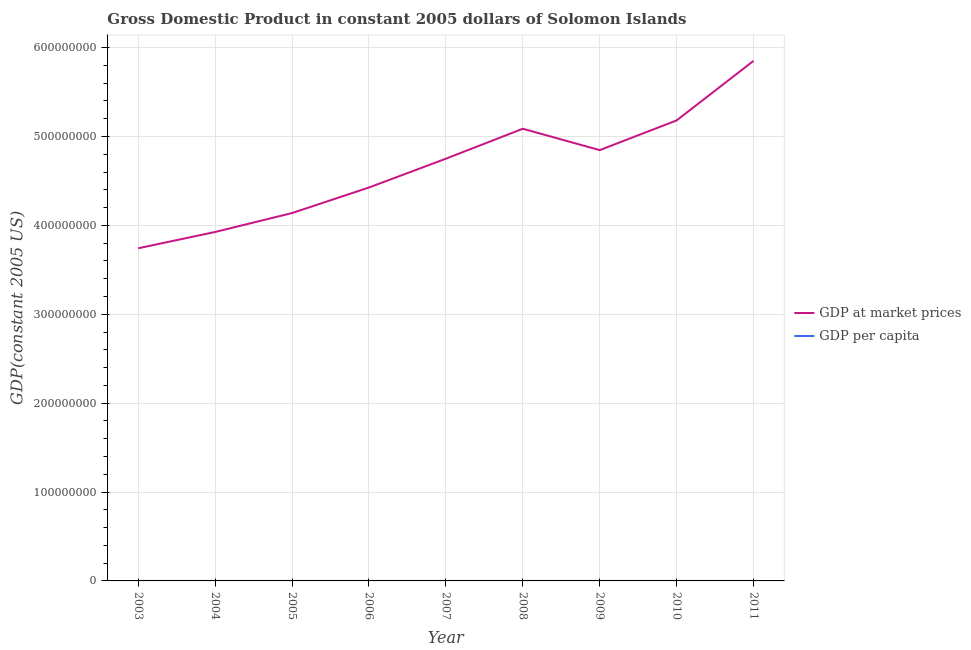How many different coloured lines are there?
Give a very brief answer. 2. Is the number of lines equal to the number of legend labels?
Your answer should be compact. Yes. What is the gdp per capita in 2009?
Ensure brevity in your answer.  941.62. Across all years, what is the maximum gdp per capita?
Provide a short and direct response. 1088.31. Across all years, what is the minimum gdp per capita?
Provide a succinct answer. 838.56. In which year was the gdp at market prices minimum?
Keep it short and to the point. 2003. What is the total gdp at market prices in the graph?
Offer a very short reply. 4.20e+09. What is the difference between the gdp at market prices in 2005 and that in 2011?
Ensure brevity in your answer.  -1.71e+08. What is the difference between the gdp per capita in 2004 and the gdp at market prices in 2007?
Your answer should be very brief. -4.75e+08. What is the average gdp per capita per year?
Provide a short and direct response. 943.3. In the year 2011, what is the difference between the gdp per capita and gdp at market prices?
Your answer should be very brief. -5.85e+08. In how many years, is the gdp at market prices greater than 220000000 US$?
Keep it short and to the point. 9. What is the ratio of the gdp at market prices in 2004 to that in 2006?
Your answer should be compact. 0.89. Is the gdp at market prices in 2006 less than that in 2008?
Provide a succinct answer. Yes. Is the difference between the gdp at market prices in 2004 and 2007 greater than the difference between the gdp per capita in 2004 and 2007?
Your answer should be very brief. No. What is the difference between the highest and the second highest gdp at market prices?
Your response must be concise. 6.70e+07. What is the difference between the highest and the lowest gdp per capita?
Your answer should be very brief. 249.75. Is the sum of the gdp per capita in 2004 and 2009 greater than the maximum gdp at market prices across all years?
Provide a succinct answer. No. Is the gdp per capita strictly less than the gdp at market prices over the years?
Your answer should be compact. Yes. How many lines are there?
Your answer should be compact. 2. How many years are there in the graph?
Offer a terse response. 9. Does the graph contain grids?
Your answer should be very brief. Yes. What is the title of the graph?
Make the answer very short. Gross Domestic Product in constant 2005 dollars of Solomon Islands. What is the label or title of the X-axis?
Provide a succinct answer. Year. What is the label or title of the Y-axis?
Give a very brief answer. GDP(constant 2005 US). What is the GDP(constant 2005 US) of GDP at market prices in 2003?
Your answer should be very brief. 3.74e+08. What is the GDP(constant 2005 US) of GDP per capita in 2003?
Your response must be concise. 838.56. What is the GDP(constant 2005 US) in GDP at market prices in 2004?
Provide a succinct answer. 3.93e+08. What is the GDP(constant 2005 US) in GDP per capita in 2004?
Your response must be concise. 857.56. What is the GDP(constant 2005 US) of GDP at market prices in 2005?
Offer a terse response. 4.14e+08. What is the GDP(constant 2005 US) in GDP per capita in 2005?
Offer a very short reply. 881.96. What is the GDP(constant 2005 US) in GDP at market prices in 2006?
Make the answer very short. 4.43e+08. What is the GDP(constant 2005 US) in GDP per capita in 2006?
Offer a terse response. 920.84. What is the GDP(constant 2005 US) of GDP at market prices in 2007?
Offer a very short reply. 4.75e+08. What is the GDP(constant 2005 US) in GDP per capita in 2007?
Provide a short and direct response. 965.44. What is the GDP(constant 2005 US) in GDP at market prices in 2008?
Offer a terse response. 5.09e+08. What is the GDP(constant 2005 US) in GDP per capita in 2008?
Make the answer very short. 1010.65. What is the GDP(constant 2005 US) of GDP at market prices in 2009?
Give a very brief answer. 4.85e+08. What is the GDP(constant 2005 US) of GDP per capita in 2009?
Ensure brevity in your answer.  941.62. What is the GDP(constant 2005 US) of GDP at market prices in 2010?
Offer a very short reply. 5.18e+08. What is the GDP(constant 2005 US) of GDP per capita in 2010?
Your response must be concise. 984.73. What is the GDP(constant 2005 US) of GDP at market prices in 2011?
Provide a short and direct response. 5.85e+08. What is the GDP(constant 2005 US) of GDP per capita in 2011?
Give a very brief answer. 1088.31. Across all years, what is the maximum GDP(constant 2005 US) in GDP at market prices?
Your answer should be very brief. 5.85e+08. Across all years, what is the maximum GDP(constant 2005 US) of GDP per capita?
Your answer should be very brief. 1088.31. Across all years, what is the minimum GDP(constant 2005 US) of GDP at market prices?
Make the answer very short. 3.74e+08. Across all years, what is the minimum GDP(constant 2005 US) in GDP per capita?
Your answer should be very brief. 838.56. What is the total GDP(constant 2005 US) of GDP at market prices in the graph?
Offer a very short reply. 4.20e+09. What is the total GDP(constant 2005 US) in GDP per capita in the graph?
Your response must be concise. 8489.68. What is the difference between the GDP(constant 2005 US) of GDP at market prices in 2003 and that in 2004?
Your answer should be compact. -1.83e+07. What is the difference between the GDP(constant 2005 US) in GDP per capita in 2003 and that in 2004?
Give a very brief answer. -19. What is the difference between the GDP(constant 2005 US) in GDP at market prices in 2003 and that in 2005?
Make the answer very short. -3.96e+07. What is the difference between the GDP(constant 2005 US) of GDP per capita in 2003 and that in 2005?
Offer a very short reply. -43.41. What is the difference between the GDP(constant 2005 US) of GDP at market prices in 2003 and that in 2006?
Make the answer very short. -6.84e+07. What is the difference between the GDP(constant 2005 US) in GDP per capita in 2003 and that in 2006?
Provide a succinct answer. -82.29. What is the difference between the GDP(constant 2005 US) in GDP at market prices in 2003 and that in 2007?
Your answer should be very brief. -1.01e+08. What is the difference between the GDP(constant 2005 US) of GDP per capita in 2003 and that in 2007?
Offer a very short reply. -126.88. What is the difference between the GDP(constant 2005 US) in GDP at market prices in 2003 and that in 2008?
Your answer should be very brief. -1.34e+08. What is the difference between the GDP(constant 2005 US) of GDP per capita in 2003 and that in 2008?
Your answer should be compact. -172.09. What is the difference between the GDP(constant 2005 US) in GDP at market prices in 2003 and that in 2009?
Your response must be concise. -1.10e+08. What is the difference between the GDP(constant 2005 US) of GDP per capita in 2003 and that in 2009?
Keep it short and to the point. -103.07. What is the difference between the GDP(constant 2005 US) in GDP at market prices in 2003 and that in 2010?
Keep it short and to the point. -1.44e+08. What is the difference between the GDP(constant 2005 US) of GDP per capita in 2003 and that in 2010?
Your response must be concise. -146.17. What is the difference between the GDP(constant 2005 US) in GDP at market prices in 2003 and that in 2011?
Ensure brevity in your answer.  -2.11e+08. What is the difference between the GDP(constant 2005 US) in GDP per capita in 2003 and that in 2011?
Keep it short and to the point. -249.75. What is the difference between the GDP(constant 2005 US) in GDP at market prices in 2004 and that in 2005?
Make the answer very short. -2.13e+07. What is the difference between the GDP(constant 2005 US) of GDP per capita in 2004 and that in 2005?
Ensure brevity in your answer.  -24.4. What is the difference between the GDP(constant 2005 US) of GDP at market prices in 2004 and that in 2006?
Ensure brevity in your answer.  -5.00e+07. What is the difference between the GDP(constant 2005 US) in GDP per capita in 2004 and that in 2006?
Ensure brevity in your answer.  -63.28. What is the difference between the GDP(constant 2005 US) of GDP at market prices in 2004 and that in 2007?
Ensure brevity in your answer.  -8.24e+07. What is the difference between the GDP(constant 2005 US) in GDP per capita in 2004 and that in 2007?
Give a very brief answer. -107.88. What is the difference between the GDP(constant 2005 US) in GDP at market prices in 2004 and that in 2008?
Give a very brief answer. -1.16e+08. What is the difference between the GDP(constant 2005 US) in GDP per capita in 2004 and that in 2008?
Offer a terse response. -153.09. What is the difference between the GDP(constant 2005 US) of GDP at market prices in 2004 and that in 2009?
Offer a very short reply. -9.21e+07. What is the difference between the GDP(constant 2005 US) in GDP per capita in 2004 and that in 2009?
Keep it short and to the point. -84.06. What is the difference between the GDP(constant 2005 US) of GDP at market prices in 2004 and that in 2010?
Provide a succinct answer. -1.26e+08. What is the difference between the GDP(constant 2005 US) in GDP per capita in 2004 and that in 2010?
Make the answer very short. -127.17. What is the difference between the GDP(constant 2005 US) of GDP at market prices in 2004 and that in 2011?
Your response must be concise. -1.93e+08. What is the difference between the GDP(constant 2005 US) in GDP per capita in 2004 and that in 2011?
Your answer should be very brief. -230.75. What is the difference between the GDP(constant 2005 US) of GDP at market prices in 2005 and that in 2006?
Keep it short and to the point. -2.88e+07. What is the difference between the GDP(constant 2005 US) of GDP per capita in 2005 and that in 2006?
Your answer should be very brief. -38.88. What is the difference between the GDP(constant 2005 US) in GDP at market prices in 2005 and that in 2007?
Provide a succinct answer. -6.12e+07. What is the difference between the GDP(constant 2005 US) in GDP per capita in 2005 and that in 2007?
Your answer should be very brief. -83.47. What is the difference between the GDP(constant 2005 US) of GDP at market prices in 2005 and that in 2008?
Offer a very short reply. -9.49e+07. What is the difference between the GDP(constant 2005 US) in GDP per capita in 2005 and that in 2008?
Offer a very short reply. -128.68. What is the difference between the GDP(constant 2005 US) in GDP at market prices in 2005 and that in 2009?
Provide a short and direct response. -7.08e+07. What is the difference between the GDP(constant 2005 US) of GDP per capita in 2005 and that in 2009?
Your response must be concise. -59.66. What is the difference between the GDP(constant 2005 US) in GDP at market prices in 2005 and that in 2010?
Make the answer very short. -1.04e+08. What is the difference between the GDP(constant 2005 US) of GDP per capita in 2005 and that in 2010?
Your answer should be very brief. -102.76. What is the difference between the GDP(constant 2005 US) of GDP at market prices in 2005 and that in 2011?
Provide a succinct answer. -1.71e+08. What is the difference between the GDP(constant 2005 US) of GDP per capita in 2005 and that in 2011?
Offer a very short reply. -206.35. What is the difference between the GDP(constant 2005 US) of GDP at market prices in 2006 and that in 2007?
Make the answer very short. -3.24e+07. What is the difference between the GDP(constant 2005 US) of GDP per capita in 2006 and that in 2007?
Ensure brevity in your answer.  -44.59. What is the difference between the GDP(constant 2005 US) of GDP at market prices in 2006 and that in 2008?
Your response must be concise. -6.61e+07. What is the difference between the GDP(constant 2005 US) in GDP per capita in 2006 and that in 2008?
Your answer should be very brief. -89.81. What is the difference between the GDP(constant 2005 US) of GDP at market prices in 2006 and that in 2009?
Offer a terse response. -4.21e+07. What is the difference between the GDP(constant 2005 US) in GDP per capita in 2006 and that in 2009?
Your answer should be compact. -20.78. What is the difference between the GDP(constant 2005 US) in GDP at market prices in 2006 and that in 2010?
Offer a very short reply. -7.55e+07. What is the difference between the GDP(constant 2005 US) of GDP per capita in 2006 and that in 2010?
Your response must be concise. -63.88. What is the difference between the GDP(constant 2005 US) in GDP at market prices in 2006 and that in 2011?
Your answer should be compact. -1.42e+08. What is the difference between the GDP(constant 2005 US) in GDP per capita in 2006 and that in 2011?
Your answer should be very brief. -167.47. What is the difference between the GDP(constant 2005 US) of GDP at market prices in 2007 and that in 2008?
Give a very brief answer. -3.37e+07. What is the difference between the GDP(constant 2005 US) in GDP per capita in 2007 and that in 2008?
Offer a terse response. -45.21. What is the difference between the GDP(constant 2005 US) in GDP at market prices in 2007 and that in 2009?
Provide a succinct answer. -9.65e+06. What is the difference between the GDP(constant 2005 US) of GDP per capita in 2007 and that in 2009?
Offer a very short reply. 23.81. What is the difference between the GDP(constant 2005 US) of GDP at market prices in 2007 and that in 2010?
Ensure brevity in your answer.  -4.31e+07. What is the difference between the GDP(constant 2005 US) in GDP per capita in 2007 and that in 2010?
Offer a very short reply. -19.29. What is the difference between the GDP(constant 2005 US) in GDP at market prices in 2007 and that in 2011?
Make the answer very short. -1.10e+08. What is the difference between the GDP(constant 2005 US) of GDP per capita in 2007 and that in 2011?
Provide a succinct answer. -122.87. What is the difference between the GDP(constant 2005 US) of GDP at market prices in 2008 and that in 2009?
Offer a terse response. 2.41e+07. What is the difference between the GDP(constant 2005 US) in GDP per capita in 2008 and that in 2009?
Provide a succinct answer. 69.03. What is the difference between the GDP(constant 2005 US) of GDP at market prices in 2008 and that in 2010?
Keep it short and to the point. -9.37e+06. What is the difference between the GDP(constant 2005 US) in GDP per capita in 2008 and that in 2010?
Your answer should be compact. 25.92. What is the difference between the GDP(constant 2005 US) of GDP at market prices in 2008 and that in 2011?
Your answer should be very brief. -7.64e+07. What is the difference between the GDP(constant 2005 US) in GDP per capita in 2008 and that in 2011?
Provide a short and direct response. -77.66. What is the difference between the GDP(constant 2005 US) in GDP at market prices in 2009 and that in 2010?
Ensure brevity in your answer.  -3.34e+07. What is the difference between the GDP(constant 2005 US) in GDP per capita in 2009 and that in 2010?
Your answer should be very brief. -43.1. What is the difference between the GDP(constant 2005 US) in GDP at market prices in 2009 and that in 2011?
Your answer should be compact. -1.00e+08. What is the difference between the GDP(constant 2005 US) of GDP per capita in 2009 and that in 2011?
Keep it short and to the point. -146.69. What is the difference between the GDP(constant 2005 US) of GDP at market prices in 2010 and that in 2011?
Ensure brevity in your answer.  -6.70e+07. What is the difference between the GDP(constant 2005 US) of GDP per capita in 2010 and that in 2011?
Make the answer very short. -103.58. What is the difference between the GDP(constant 2005 US) in GDP at market prices in 2003 and the GDP(constant 2005 US) in GDP per capita in 2004?
Your answer should be compact. 3.74e+08. What is the difference between the GDP(constant 2005 US) in GDP at market prices in 2003 and the GDP(constant 2005 US) in GDP per capita in 2005?
Your response must be concise. 3.74e+08. What is the difference between the GDP(constant 2005 US) in GDP at market prices in 2003 and the GDP(constant 2005 US) in GDP per capita in 2006?
Provide a short and direct response. 3.74e+08. What is the difference between the GDP(constant 2005 US) of GDP at market prices in 2003 and the GDP(constant 2005 US) of GDP per capita in 2007?
Your response must be concise. 3.74e+08. What is the difference between the GDP(constant 2005 US) of GDP at market prices in 2003 and the GDP(constant 2005 US) of GDP per capita in 2008?
Your answer should be compact. 3.74e+08. What is the difference between the GDP(constant 2005 US) of GDP at market prices in 2003 and the GDP(constant 2005 US) of GDP per capita in 2009?
Ensure brevity in your answer.  3.74e+08. What is the difference between the GDP(constant 2005 US) in GDP at market prices in 2003 and the GDP(constant 2005 US) in GDP per capita in 2010?
Offer a terse response. 3.74e+08. What is the difference between the GDP(constant 2005 US) of GDP at market prices in 2003 and the GDP(constant 2005 US) of GDP per capita in 2011?
Your answer should be very brief. 3.74e+08. What is the difference between the GDP(constant 2005 US) in GDP at market prices in 2004 and the GDP(constant 2005 US) in GDP per capita in 2005?
Provide a short and direct response. 3.93e+08. What is the difference between the GDP(constant 2005 US) in GDP at market prices in 2004 and the GDP(constant 2005 US) in GDP per capita in 2006?
Your response must be concise. 3.93e+08. What is the difference between the GDP(constant 2005 US) in GDP at market prices in 2004 and the GDP(constant 2005 US) in GDP per capita in 2007?
Ensure brevity in your answer.  3.93e+08. What is the difference between the GDP(constant 2005 US) of GDP at market prices in 2004 and the GDP(constant 2005 US) of GDP per capita in 2008?
Your answer should be compact. 3.93e+08. What is the difference between the GDP(constant 2005 US) of GDP at market prices in 2004 and the GDP(constant 2005 US) of GDP per capita in 2009?
Offer a terse response. 3.93e+08. What is the difference between the GDP(constant 2005 US) in GDP at market prices in 2004 and the GDP(constant 2005 US) in GDP per capita in 2010?
Your response must be concise. 3.93e+08. What is the difference between the GDP(constant 2005 US) in GDP at market prices in 2004 and the GDP(constant 2005 US) in GDP per capita in 2011?
Provide a succinct answer. 3.93e+08. What is the difference between the GDP(constant 2005 US) of GDP at market prices in 2005 and the GDP(constant 2005 US) of GDP per capita in 2006?
Your response must be concise. 4.14e+08. What is the difference between the GDP(constant 2005 US) of GDP at market prices in 2005 and the GDP(constant 2005 US) of GDP per capita in 2007?
Offer a terse response. 4.14e+08. What is the difference between the GDP(constant 2005 US) in GDP at market prices in 2005 and the GDP(constant 2005 US) in GDP per capita in 2008?
Offer a terse response. 4.14e+08. What is the difference between the GDP(constant 2005 US) of GDP at market prices in 2005 and the GDP(constant 2005 US) of GDP per capita in 2009?
Give a very brief answer. 4.14e+08. What is the difference between the GDP(constant 2005 US) of GDP at market prices in 2005 and the GDP(constant 2005 US) of GDP per capita in 2010?
Offer a terse response. 4.14e+08. What is the difference between the GDP(constant 2005 US) of GDP at market prices in 2005 and the GDP(constant 2005 US) of GDP per capita in 2011?
Your response must be concise. 4.14e+08. What is the difference between the GDP(constant 2005 US) in GDP at market prices in 2006 and the GDP(constant 2005 US) in GDP per capita in 2007?
Ensure brevity in your answer.  4.43e+08. What is the difference between the GDP(constant 2005 US) of GDP at market prices in 2006 and the GDP(constant 2005 US) of GDP per capita in 2008?
Provide a short and direct response. 4.43e+08. What is the difference between the GDP(constant 2005 US) of GDP at market prices in 2006 and the GDP(constant 2005 US) of GDP per capita in 2009?
Provide a short and direct response. 4.43e+08. What is the difference between the GDP(constant 2005 US) of GDP at market prices in 2006 and the GDP(constant 2005 US) of GDP per capita in 2010?
Offer a terse response. 4.43e+08. What is the difference between the GDP(constant 2005 US) in GDP at market prices in 2006 and the GDP(constant 2005 US) in GDP per capita in 2011?
Offer a very short reply. 4.43e+08. What is the difference between the GDP(constant 2005 US) in GDP at market prices in 2007 and the GDP(constant 2005 US) in GDP per capita in 2008?
Ensure brevity in your answer.  4.75e+08. What is the difference between the GDP(constant 2005 US) of GDP at market prices in 2007 and the GDP(constant 2005 US) of GDP per capita in 2009?
Your answer should be compact. 4.75e+08. What is the difference between the GDP(constant 2005 US) of GDP at market prices in 2007 and the GDP(constant 2005 US) of GDP per capita in 2010?
Keep it short and to the point. 4.75e+08. What is the difference between the GDP(constant 2005 US) of GDP at market prices in 2007 and the GDP(constant 2005 US) of GDP per capita in 2011?
Provide a short and direct response. 4.75e+08. What is the difference between the GDP(constant 2005 US) in GDP at market prices in 2008 and the GDP(constant 2005 US) in GDP per capita in 2009?
Provide a succinct answer. 5.09e+08. What is the difference between the GDP(constant 2005 US) of GDP at market prices in 2008 and the GDP(constant 2005 US) of GDP per capita in 2010?
Provide a short and direct response. 5.09e+08. What is the difference between the GDP(constant 2005 US) of GDP at market prices in 2008 and the GDP(constant 2005 US) of GDP per capita in 2011?
Offer a terse response. 5.09e+08. What is the difference between the GDP(constant 2005 US) of GDP at market prices in 2009 and the GDP(constant 2005 US) of GDP per capita in 2010?
Your answer should be very brief. 4.85e+08. What is the difference between the GDP(constant 2005 US) of GDP at market prices in 2009 and the GDP(constant 2005 US) of GDP per capita in 2011?
Give a very brief answer. 4.85e+08. What is the difference between the GDP(constant 2005 US) in GDP at market prices in 2010 and the GDP(constant 2005 US) in GDP per capita in 2011?
Offer a terse response. 5.18e+08. What is the average GDP(constant 2005 US) of GDP at market prices per year?
Ensure brevity in your answer.  4.66e+08. What is the average GDP(constant 2005 US) in GDP per capita per year?
Offer a terse response. 943.3. In the year 2003, what is the difference between the GDP(constant 2005 US) in GDP at market prices and GDP(constant 2005 US) in GDP per capita?
Your answer should be compact. 3.74e+08. In the year 2004, what is the difference between the GDP(constant 2005 US) in GDP at market prices and GDP(constant 2005 US) in GDP per capita?
Provide a succinct answer. 3.93e+08. In the year 2005, what is the difference between the GDP(constant 2005 US) in GDP at market prices and GDP(constant 2005 US) in GDP per capita?
Ensure brevity in your answer.  4.14e+08. In the year 2006, what is the difference between the GDP(constant 2005 US) of GDP at market prices and GDP(constant 2005 US) of GDP per capita?
Keep it short and to the point. 4.43e+08. In the year 2007, what is the difference between the GDP(constant 2005 US) of GDP at market prices and GDP(constant 2005 US) of GDP per capita?
Make the answer very short. 4.75e+08. In the year 2008, what is the difference between the GDP(constant 2005 US) of GDP at market prices and GDP(constant 2005 US) of GDP per capita?
Give a very brief answer. 5.09e+08. In the year 2009, what is the difference between the GDP(constant 2005 US) of GDP at market prices and GDP(constant 2005 US) of GDP per capita?
Keep it short and to the point. 4.85e+08. In the year 2010, what is the difference between the GDP(constant 2005 US) in GDP at market prices and GDP(constant 2005 US) in GDP per capita?
Give a very brief answer. 5.18e+08. In the year 2011, what is the difference between the GDP(constant 2005 US) in GDP at market prices and GDP(constant 2005 US) in GDP per capita?
Your answer should be very brief. 5.85e+08. What is the ratio of the GDP(constant 2005 US) in GDP at market prices in 2003 to that in 2004?
Keep it short and to the point. 0.95. What is the ratio of the GDP(constant 2005 US) of GDP per capita in 2003 to that in 2004?
Give a very brief answer. 0.98. What is the ratio of the GDP(constant 2005 US) of GDP at market prices in 2003 to that in 2005?
Provide a short and direct response. 0.9. What is the ratio of the GDP(constant 2005 US) in GDP per capita in 2003 to that in 2005?
Your answer should be very brief. 0.95. What is the ratio of the GDP(constant 2005 US) of GDP at market prices in 2003 to that in 2006?
Offer a very short reply. 0.85. What is the ratio of the GDP(constant 2005 US) in GDP per capita in 2003 to that in 2006?
Ensure brevity in your answer.  0.91. What is the ratio of the GDP(constant 2005 US) of GDP at market prices in 2003 to that in 2007?
Provide a short and direct response. 0.79. What is the ratio of the GDP(constant 2005 US) in GDP per capita in 2003 to that in 2007?
Keep it short and to the point. 0.87. What is the ratio of the GDP(constant 2005 US) of GDP at market prices in 2003 to that in 2008?
Your answer should be very brief. 0.74. What is the ratio of the GDP(constant 2005 US) in GDP per capita in 2003 to that in 2008?
Your answer should be very brief. 0.83. What is the ratio of the GDP(constant 2005 US) of GDP at market prices in 2003 to that in 2009?
Your answer should be very brief. 0.77. What is the ratio of the GDP(constant 2005 US) in GDP per capita in 2003 to that in 2009?
Make the answer very short. 0.89. What is the ratio of the GDP(constant 2005 US) in GDP at market prices in 2003 to that in 2010?
Ensure brevity in your answer.  0.72. What is the ratio of the GDP(constant 2005 US) in GDP per capita in 2003 to that in 2010?
Provide a short and direct response. 0.85. What is the ratio of the GDP(constant 2005 US) of GDP at market prices in 2003 to that in 2011?
Your answer should be very brief. 0.64. What is the ratio of the GDP(constant 2005 US) in GDP per capita in 2003 to that in 2011?
Offer a terse response. 0.77. What is the ratio of the GDP(constant 2005 US) in GDP at market prices in 2004 to that in 2005?
Your response must be concise. 0.95. What is the ratio of the GDP(constant 2005 US) of GDP per capita in 2004 to that in 2005?
Provide a succinct answer. 0.97. What is the ratio of the GDP(constant 2005 US) in GDP at market prices in 2004 to that in 2006?
Ensure brevity in your answer.  0.89. What is the ratio of the GDP(constant 2005 US) in GDP per capita in 2004 to that in 2006?
Provide a short and direct response. 0.93. What is the ratio of the GDP(constant 2005 US) in GDP at market prices in 2004 to that in 2007?
Your response must be concise. 0.83. What is the ratio of the GDP(constant 2005 US) of GDP per capita in 2004 to that in 2007?
Offer a very short reply. 0.89. What is the ratio of the GDP(constant 2005 US) of GDP at market prices in 2004 to that in 2008?
Offer a very short reply. 0.77. What is the ratio of the GDP(constant 2005 US) of GDP per capita in 2004 to that in 2008?
Offer a terse response. 0.85. What is the ratio of the GDP(constant 2005 US) of GDP at market prices in 2004 to that in 2009?
Provide a succinct answer. 0.81. What is the ratio of the GDP(constant 2005 US) of GDP per capita in 2004 to that in 2009?
Give a very brief answer. 0.91. What is the ratio of the GDP(constant 2005 US) in GDP at market prices in 2004 to that in 2010?
Give a very brief answer. 0.76. What is the ratio of the GDP(constant 2005 US) in GDP per capita in 2004 to that in 2010?
Your answer should be compact. 0.87. What is the ratio of the GDP(constant 2005 US) of GDP at market prices in 2004 to that in 2011?
Give a very brief answer. 0.67. What is the ratio of the GDP(constant 2005 US) in GDP per capita in 2004 to that in 2011?
Provide a succinct answer. 0.79. What is the ratio of the GDP(constant 2005 US) in GDP at market prices in 2005 to that in 2006?
Your response must be concise. 0.94. What is the ratio of the GDP(constant 2005 US) in GDP per capita in 2005 to that in 2006?
Offer a very short reply. 0.96. What is the ratio of the GDP(constant 2005 US) of GDP at market prices in 2005 to that in 2007?
Offer a very short reply. 0.87. What is the ratio of the GDP(constant 2005 US) in GDP per capita in 2005 to that in 2007?
Ensure brevity in your answer.  0.91. What is the ratio of the GDP(constant 2005 US) in GDP at market prices in 2005 to that in 2008?
Your response must be concise. 0.81. What is the ratio of the GDP(constant 2005 US) of GDP per capita in 2005 to that in 2008?
Your response must be concise. 0.87. What is the ratio of the GDP(constant 2005 US) in GDP at market prices in 2005 to that in 2009?
Ensure brevity in your answer.  0.85. What is the ratio of the GDP(constant 2005 US) of GDP per capita in 2005 to that in 2009?
Offer a terse response. 0.94. What is the ratio of the GDP(constant 2005 US) in GDP at market prices in 2005 to that in 2010?
Your answer should be very brief. 0.8. What is the ratio of the GDP(constant 2005 US) in GDP per capita in 2005 to that in 2010?
Provide a short and direct response. 0.9. What is the ratio of the GDP(constant 2005 US) in GDP at market prices in 2005 to that in 2011?
Offer a very short reply. 0.71. What is the ratio of the GDP(constant 2005 US) in GDP per capita in 2005 to that in 2011?
Your answer should be compact. 0.81. What is the ratio of the GDP(constant 2005 US) of GDP at market prices in 2006 to that in 2007?
Offer a very short reply. 0.93. What is the ratio of the GDP(constant 2005 US) of GDP per capita in 2006 to that in 2007?
Give a very brief answer. 0.95. What is the ratio of the GDP(constant 2005 US) in GDP at market prices in 2006 to that in 2008?
Offer a very short reply. 0.87. What is the ratio of the GDP(constant 2005 US) in GDP per capita in 2006 to that in 2008?
Make the answer very short. 0.91. What is the ratio of the GDP(constant 2005 US) in GDP at market prices in 2006 to that in 2009?
Offer a very short reply. 0.91. What is the ratio of the GDP(constant 2005 US) in GDP per capita in 2006 to that in 2009?
Keep it short and to the point. 0.98. What is the ratio of the GDP(constant 2005 US) of GDP at market prices in 2006 to that in 2010?
Offer a terse response. 0.85. What is the ratio of the GDP(constant 2005 US) of GDP per capita in 2006 to that in 2010?
Keep it short and to the point. 0.94. What is the ratio of the GDP(constant 2005 US) of GDP at market prices in 2006 to that in 2011?
Make the answer very short. 0.76. What is the ratio of the GDP(constant 2005 US) of GDP per capita in 2006 to that in 2011?
Offer a terse response. 0.85. What is the ratio of the GDP(constant 2005 US) in GDP at market prices in 2007 to that in 2008?
Offer a very short reply. 0.93. What is the ratio of the GDP(constant 2005 US) of GDP per capita in 2007 to that in 2008?
Offer a terse response. 0.96. What is the ratio of the GDP(constant 2005 US) in GDP at market prices in 2007 to that in 2009?
Keep it short and to the point. 0.98. What is the ratio of the GDP(constant 2005 US) in GDP per capita in 2007 to that in 2009?
Offer a very short reply. 1.03. What is the ratio of the GDP(constant 2005 US) in GDP at market prices in 2007 to that in 2010?
Provide a short and direct response. 0.92. What is the ratio of the GDP(constant 2005 US) in GDP per capita in 2007 to that in 2010?
Provide a succinct answer. 0.98. What is the ratio of the GDP(constant 2005 US) in GDP at market prices in 2007 to that in 2011?
Give a very brief answer. 0.81. What is the ratio of the GDP(constant 2005 US) in GDP per capita in 2007 to that in 2011?
Make the answer very short. 0.89. What is the ratio of the GDP(constant 2005 US) of GDP at market prices in 2008 to that in 2009?
Ensure brevity in your answer.  1.05. What is the ratio of the GDP(constant 2005 US) in GDP per capita in 2008 to that in 2009?
Offer a very short reply. 1.07. What is the ratio of the GDP(constant 2005 US) in GDP at market prices in 2008 to that in 2010?
Ensure brevity in your answer.  0.98. What is the ratio of the GDP(constant 2005 US) of GDP per capita in 2008 to that in 2010?
Provide a succinct answer. 1.03. What is the ratio of the GDP(constant 2005 US) of GDP at market prices in 2008 to that in 2011?
Provide a succinct answer. 0.87. What is the ratio of the GDP(constant 2005 US) of GDP per capita in 2008 to that in 2011?
Ensure brevity in your answer.  0.93. What is the ratio of the GDP(constant 2005 US) in GDP at market prices in 2009 to that in 2010?
Your response must be concise. 0.94. What is the ratio of the GDP(constant 2005 US) of GDP per capita in 2009 to that in 2010?
Offer a very short reply. 0.96. What is the ratio of the GDP(constant 2005 US) of GDP at market prices in 2009 to that in 2011?
Offer a very short reply. 0.83. What is the ratio of the GDP(constant 2005 US) of GDP per capita in 2009 to that in 2011?
Give a very brief answer. 0.87. What is the ratio of the GDP(constant 2005 US) of GDP at market prices in 2010 to that in 2011?
Ensure brevity in your answer.  0.89. What is the ratio of the GDP(constant 2005 US) in GDP per capita in 2010 to that in 2011?
Your answer should be very brief. 0.9. What is the difference between the highest and the second highest GDP(constant 2005 US) in GDP at market prices?
Ensure brevity in your answer.  6.70e+07. What is the difference between the highest and the second highest GDP(constant 2005 US) in GDP per capita?
Offer a terse response. 77.66. What is the difference between the highest and the lowest GDP(constant 2005 US) of GDP at market prices?
Your answer should be compact. 2.11e+08. What is the difference between the highest and the lowest GDP(constant 2005 US) in GDP per capita?
Offer a terse response. 249.75. 